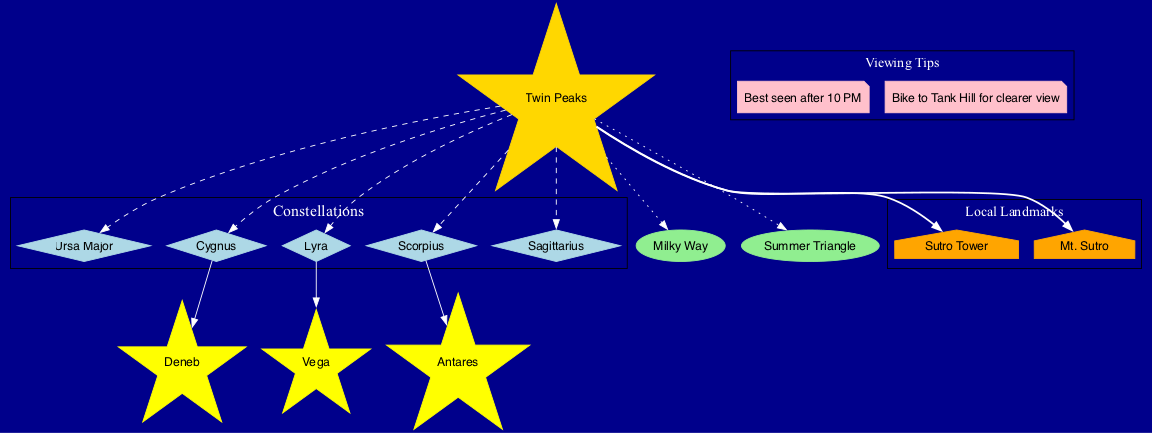What are the visible constellations from Twin Peaks? The diagram labels the constellations that can be seen from Twin Peaks, which include Ursa Major, Cygnus, Lyra, Scorpius, and Sagittarius.
Answer: Ursa Major, Cygnus, Lyra, Scorpius, Sagittarius Which notable star belongs to the Lyra constellation? The diagram indicates that Vega is the notable star associated with the constellation Lyra.
Answer: Vega How many celestial objects are listed in the diagram? By counting the nodes labeled as celestial objects in the diagram, we find there are two listed: Milky Way and Summer Triangle.
Answer: 2 What is a recommended time for best viewing? The viewing tips in the diagram suggest that the best time for viewing is after 10 PM.
Answer: After 10 PM Name a local landmark near Twin Peaks. The diagram features local landmarks including Sutro Tower and Mt. Sutro, which can be seen from Twin Peaks.
Answer: Sutro Tower What connects Twin Peaks to the constellations? The diagram uses dashed lines to connect Twin Peaks to the constellations, indicating their visibility from this location.
Answer: Dashed lines Which star is specifically labeled as belonging to Scorpius? Among the notable stars listed in the diagram, Antares is identified as the star that belongs to the Scorpius constellation.
Answer: Antares Where should I bike for a clearer view? According to the viewing tips in the diagram, biking to Tank Hill is recommended for a clearer view of the night sky.
Answer: Tank Hill What unique feature is illustrated in the diagram related to summer stargazing? The Summer Triangle, a prominent asterism in summer skies, is included among the celestial objects in the diagram.
Answer: Summer Triangle 